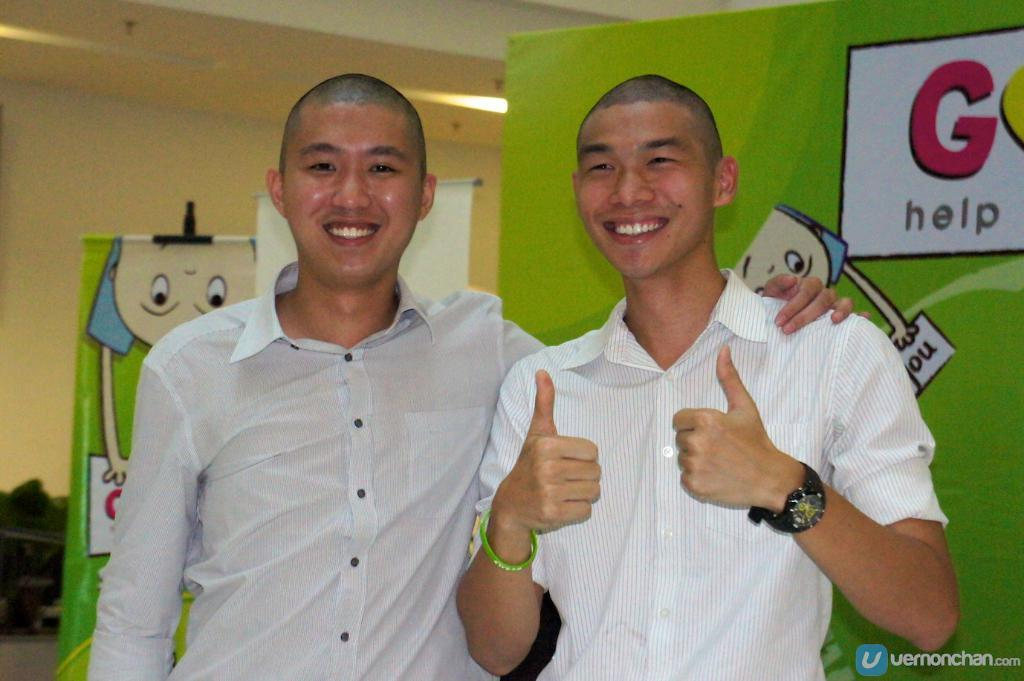What is the position of the man in the image? There is a man on the right side of the image. What is the man doing in the image? The man is smiling and showing his two thumbs. What is the man wearing in the image? The man is wearing a white color shirt. Is there anyone else in the image? Yes, there is another man standing beside him. What is the second man doing in the image? The second man is also smiling. What type of education does the man in the image have? There is no information about the man's education in the image. Can you tell me where the man's boots are located in the image? There are no boots mentioned or visible in the image. 